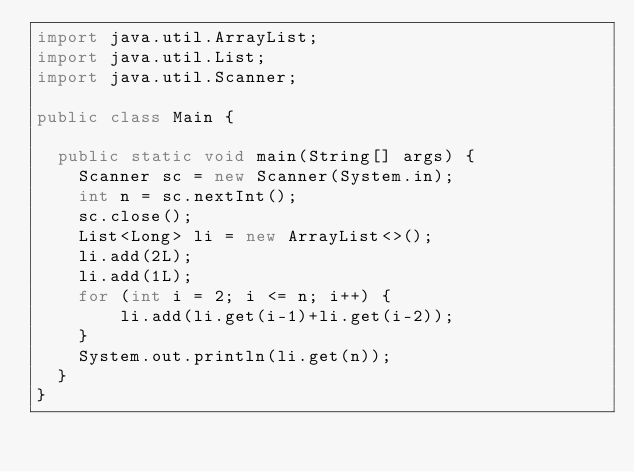Convert code to text. <code><loc_0><loc_0><loc_500><loc_500><_Java_>import java.util.ArrayList;
import java.util.List;
import java.util.Scanner;

public class Main {

	public static void main(String[] args) {
		Scanner sc = new Scanner(System.in);
		int n = sc.nextInt();
		sc.close();
		List<Long> li = new ArrayList<>();
		li.add(2L);
		li.add(1L);
		for (int i = 2; i <= n; i++) {
				li.add(li.get(i-1)+li.get(i-2));
		}
		System.out.println(li.get(n));
	}
}</code> 